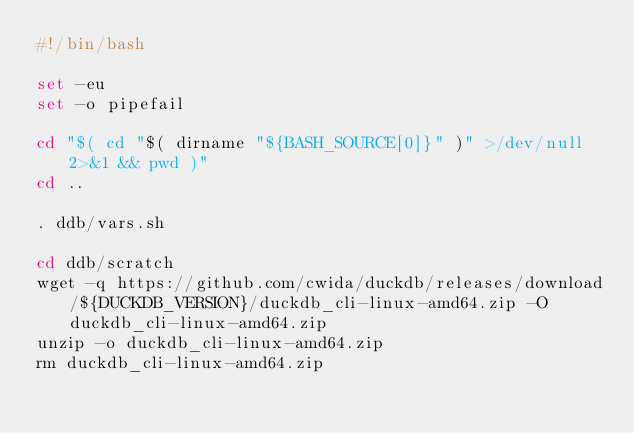<code> <loc_0><loc_0><loc_500><loc_500><_Bash_>#!/bin/bash

set -eu
set -o pipefail

cd "$( cd "$( dirname "${BASH_SOURCE[0]}" )" >/dev/null 2>&1 && pwd )"
cd ..

. ddb/vars.sh

cd ddb/scratch
wget -q https://github.com/cwida/duckdb/releases/download/${DUCKDB_VERSION}/duckdb_cli-linux-amd64.zip -O duckdb_cli-linux-amd64.zip
unzip -o duckdb_cli-linux-amd64.zip
rm duckdb_cli-linux-amd64.zip
</code> 